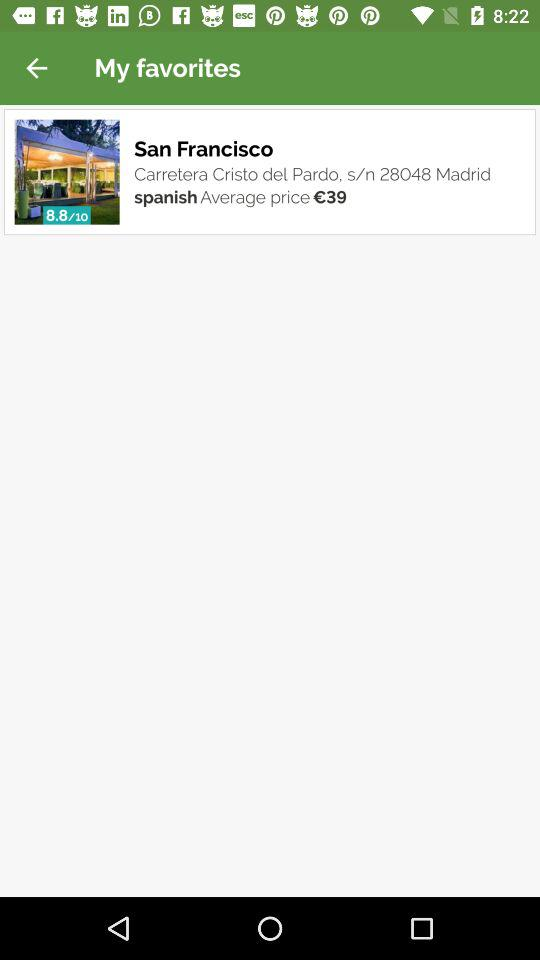How much is the total rating? The total rating is 8.8. 